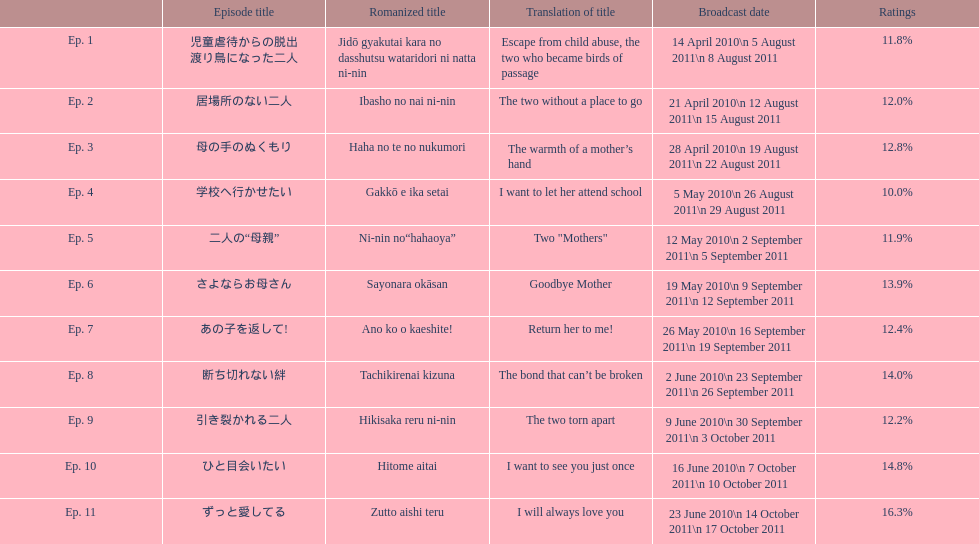In april 2010, how many episodes were shown in japan? 3. 